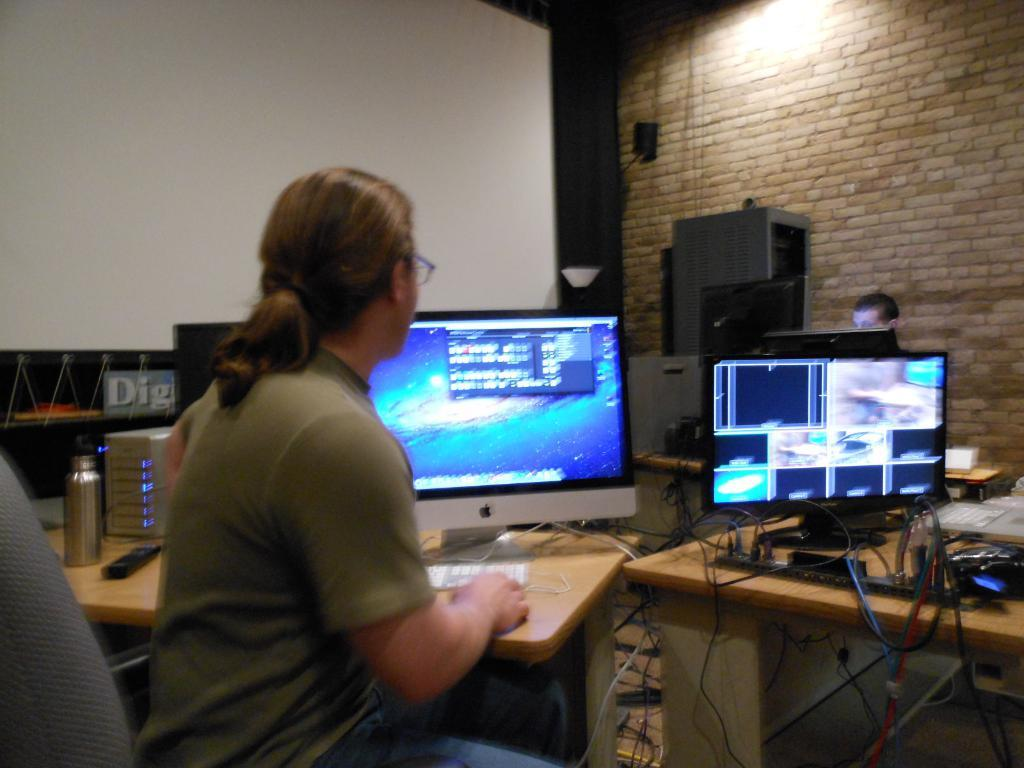<image>
Create a compact narrative representing the image presented. A man sits at a desk with computer screens, in front of a sign with the partial word Dig visible. 